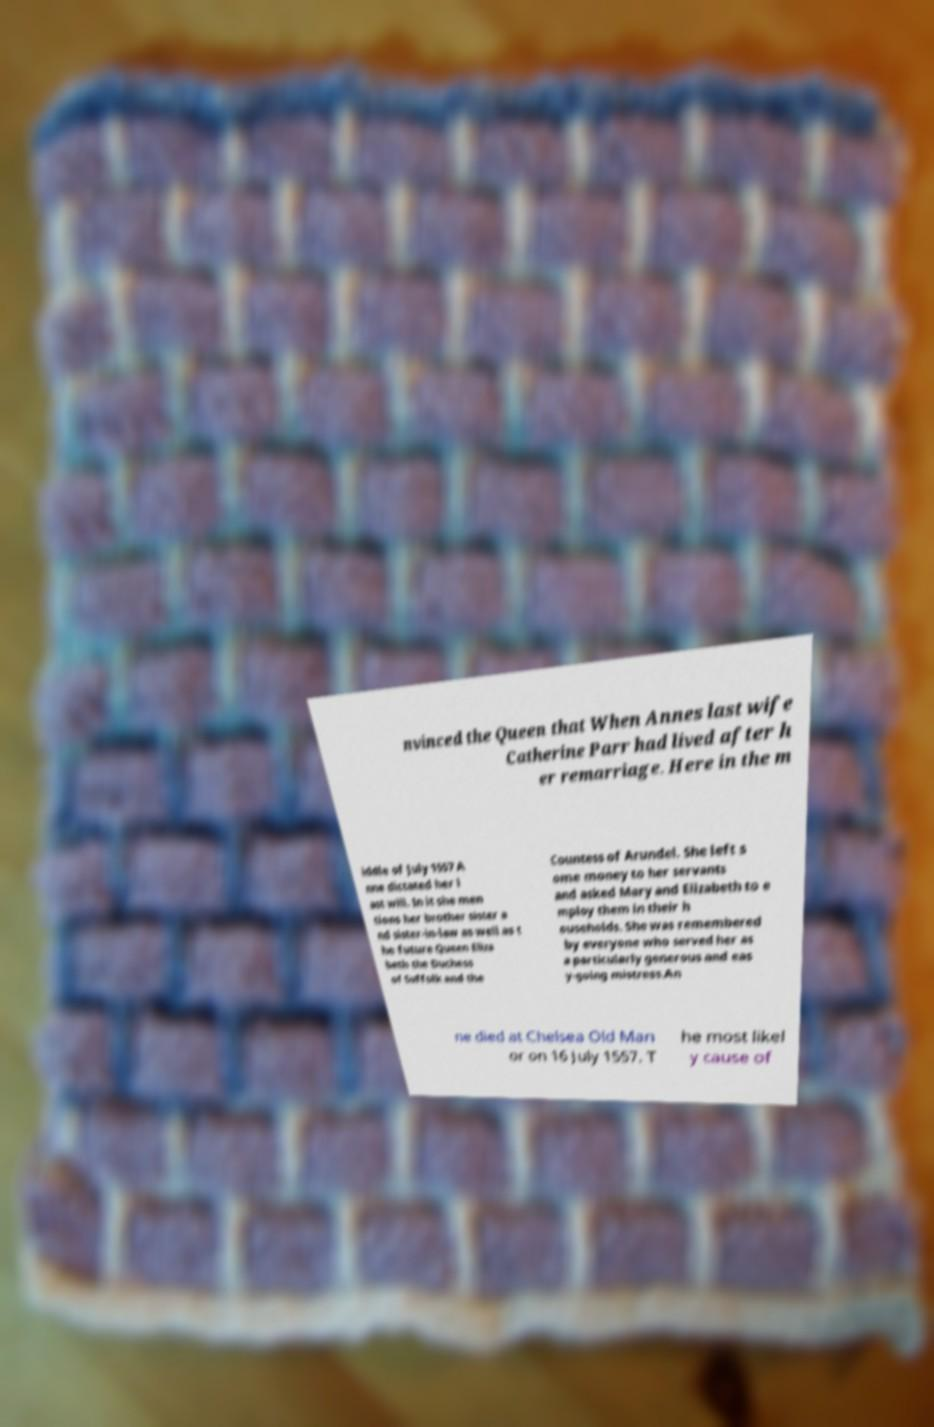Can you read and provide the text displayed in the image?This photo seems to have some interesting text. Can you extract and type it out for me? nvinced the Queen that When Annes last wife Catherine Parr had lived after h er remarriage. Here in the m iddle of July 1557 A nne dictated her l ast will. In it she men tions her brother sister a nd sister-in-law as well as t he future Queen Eliza beth the Duchess of Suffolk and the Countess of Arundel. She left s ome money to her servants and asked Mary and Elizabeth to e mploy them in their h ouseholds. She was remembered by everyone who served her as a particularly generous and eas y-going mistress.An ne died at Chelsea Old Man or on 16 July 1557. T he most likel y cause of 